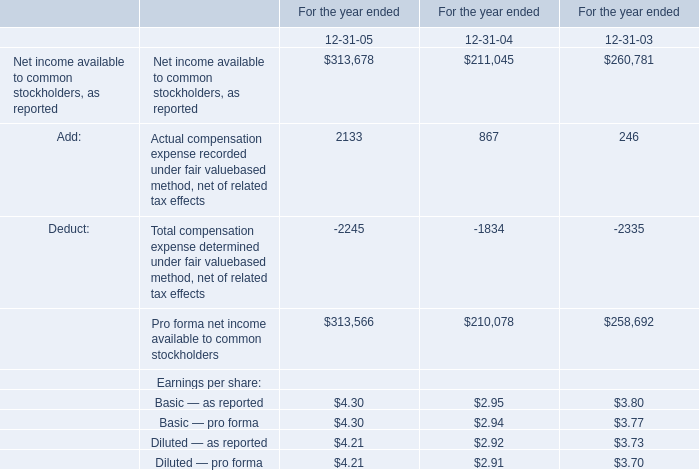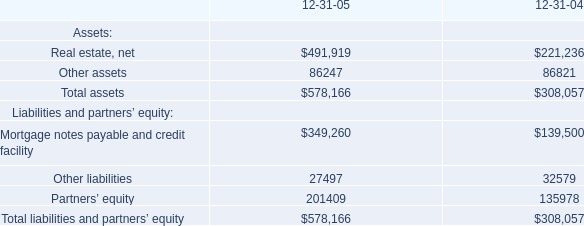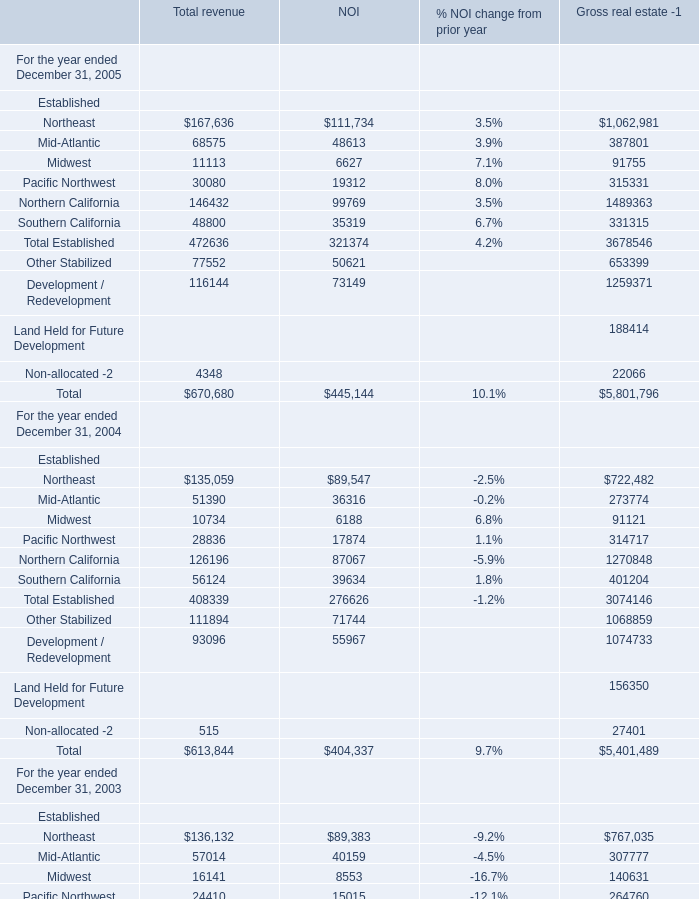How many Total revenue exceed the average of Total revenue in 2005? 
Answer: 5. 